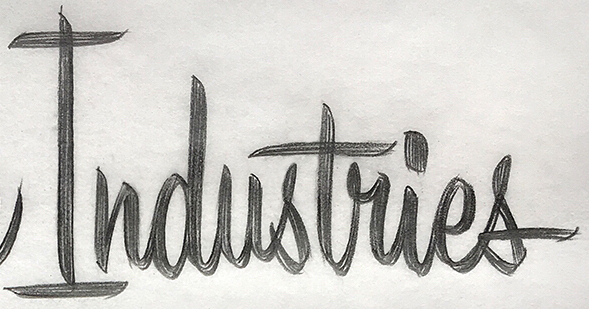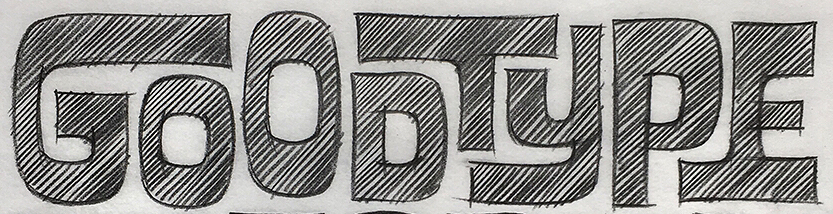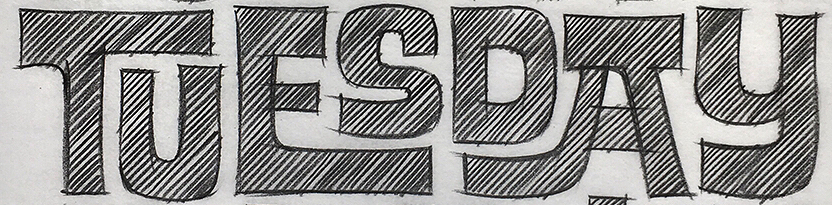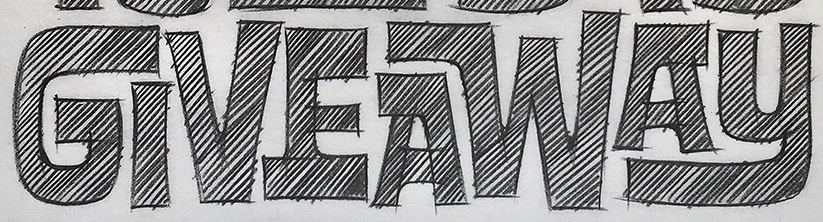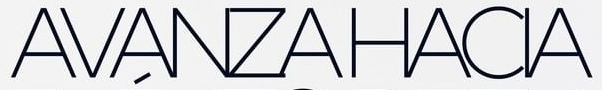Transcribe the words shown in these images in order, separated by a semicolon. Industries; GOODTYPE; TUESDAY; GIVEAWAY; AVANZAHACIA 